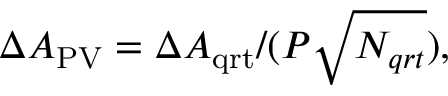<formula> <loc_0><loc_0><loc_500><loc_500>\Delta A _ { P V } = \Delta A _ { q r t } / ( P \sqrt { N _ { q r t } } ) ,</formula> 